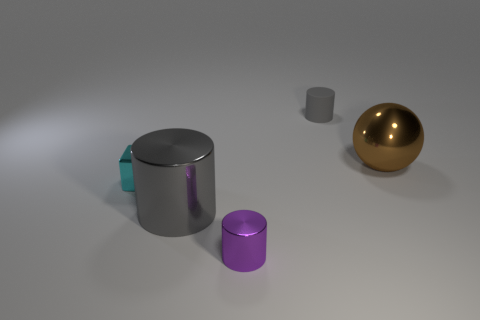How many other objects are the same material as the cyan block?
Give a very brief answer. 3. The object to the right of the small object that is behind the large thing that is behind the large cylinder is what color?
Give a very brief answer. Brown. There is a brown ball that is the same size as the gray metallic cylinder; what material is it?
Provide a short and direct response. Metal. What number of things are large things that are on the left side of the small rubber thing or brown rubber objects?
Offer a very short reply. 1. Are any small red metallic cylinders visible?
Provide a short and direct response. No. There is a gray cylinder left of the rubber cylinder; what material is it?
Your response must be concise. Metal. There is another large thing that is the same color as the matte thing; what is it made of?
Give a very brief answer. Metal. How many big objects are either brown rubber cubes or brown metallic spheres?
Keep it short and to the point. 1. The sphere is what color?
Provide a short and direct response. Brown. There is a large object that is behind the tiny cyan metallic thing; is there a gray matte cylinder that is to the right of it?
Your answer should be very brief. No. 